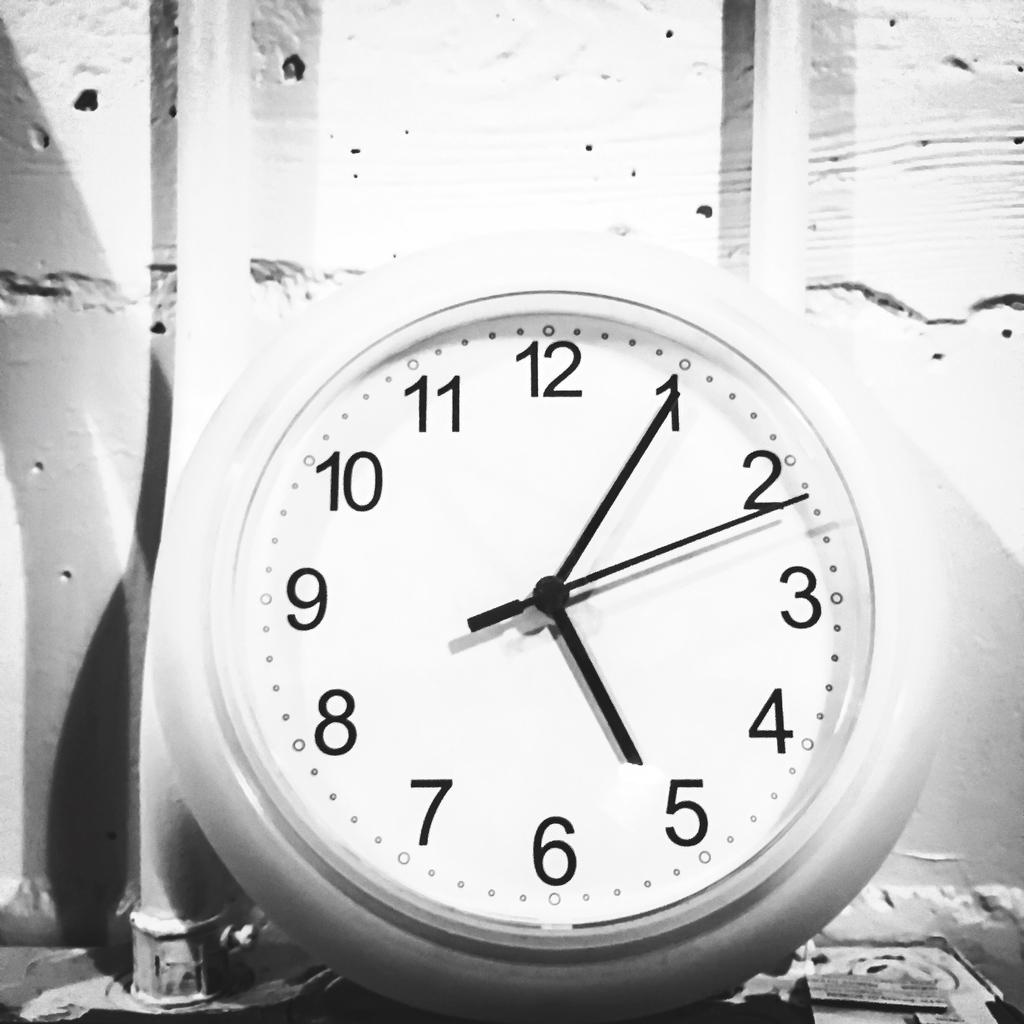<image>
Summarize the visual content of the image. A clock with the minute hand on the "1" leaning against a wall. 